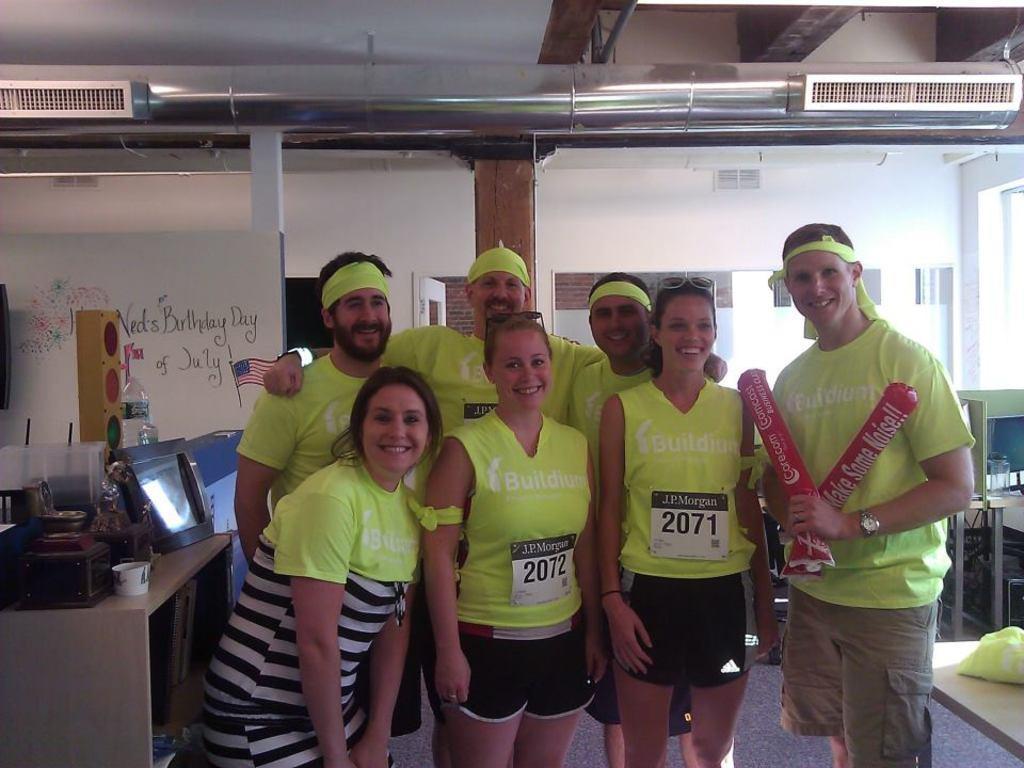Can you describe this image briefly? In this image we can see a group of people standing on the floor. In that a man is holding some balloons. On the left side of the image we can see a table containing a monitor, cup, bottle and a box on it. On the right side we can see a cover on the table. On the backside we can see some pillars, wall, a door and a roof. 